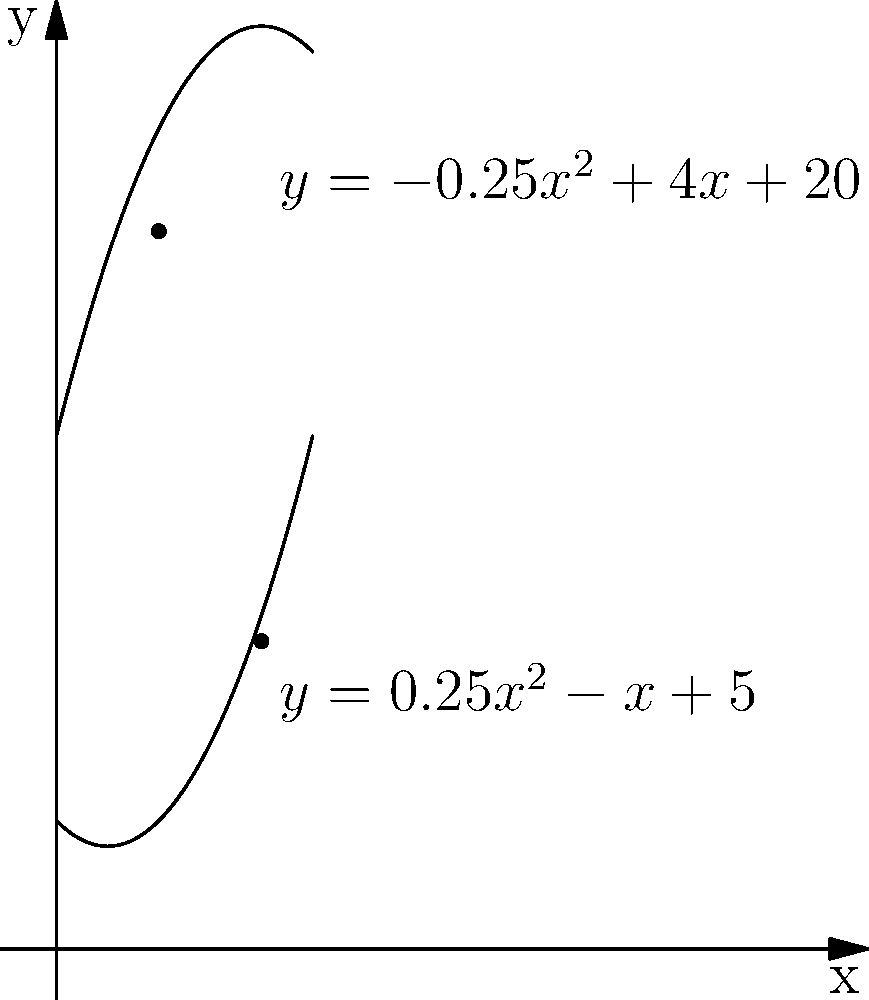Sue Donohoe, your basketball idol, is designing a new court layout. The boundaries of the court are represented by two polynomial functions: $f(x) = -0.25x^2 + 4x + 20$ and $g(x) = 0.25x^2 - x + 5$, where $x$ and $y$ are measured in meters. Calculate the area of the court between $x = 4$ and $x = 8$. To find the area between two curves, we need to:

1) Find the difference between the upper and lower functions:
   $h(x) = f(x) - g(x) = (-0.25x^2 + 4x + 20) - (0.25x^2 - x + 5)$
   $h(x) = -0.5x^2 + 5x + 15$

2) Integrate this difference from $x = 4$ to $x = 8$:
   $Area = \int_4^8 h(x) dx = \int_4^8 (-0.5x^2 + 5x + 15) dx$

3) Evaluate the integral:
   $Area = [-\frac{1}{6}x^3 + \frac{5}{2}x^2 + 15x]_4^8$
   $= (-\frac{1}{6}(8^3) + \frac{5}{2}(8^2) + 15(8)) - (-\frac{1}{6}(4^3) + \frac{5}{2}(4^2) + 15(4))$
   $= (-42.67 + 160 + 120) - (-10.67 + 40 + 60)$
   $= 237.33 - 89.33$
   $= 148$

Therefore, the area of the court between $x = 4$ and $x = 8$ is 148 square meters.
Answer: 148 m² 